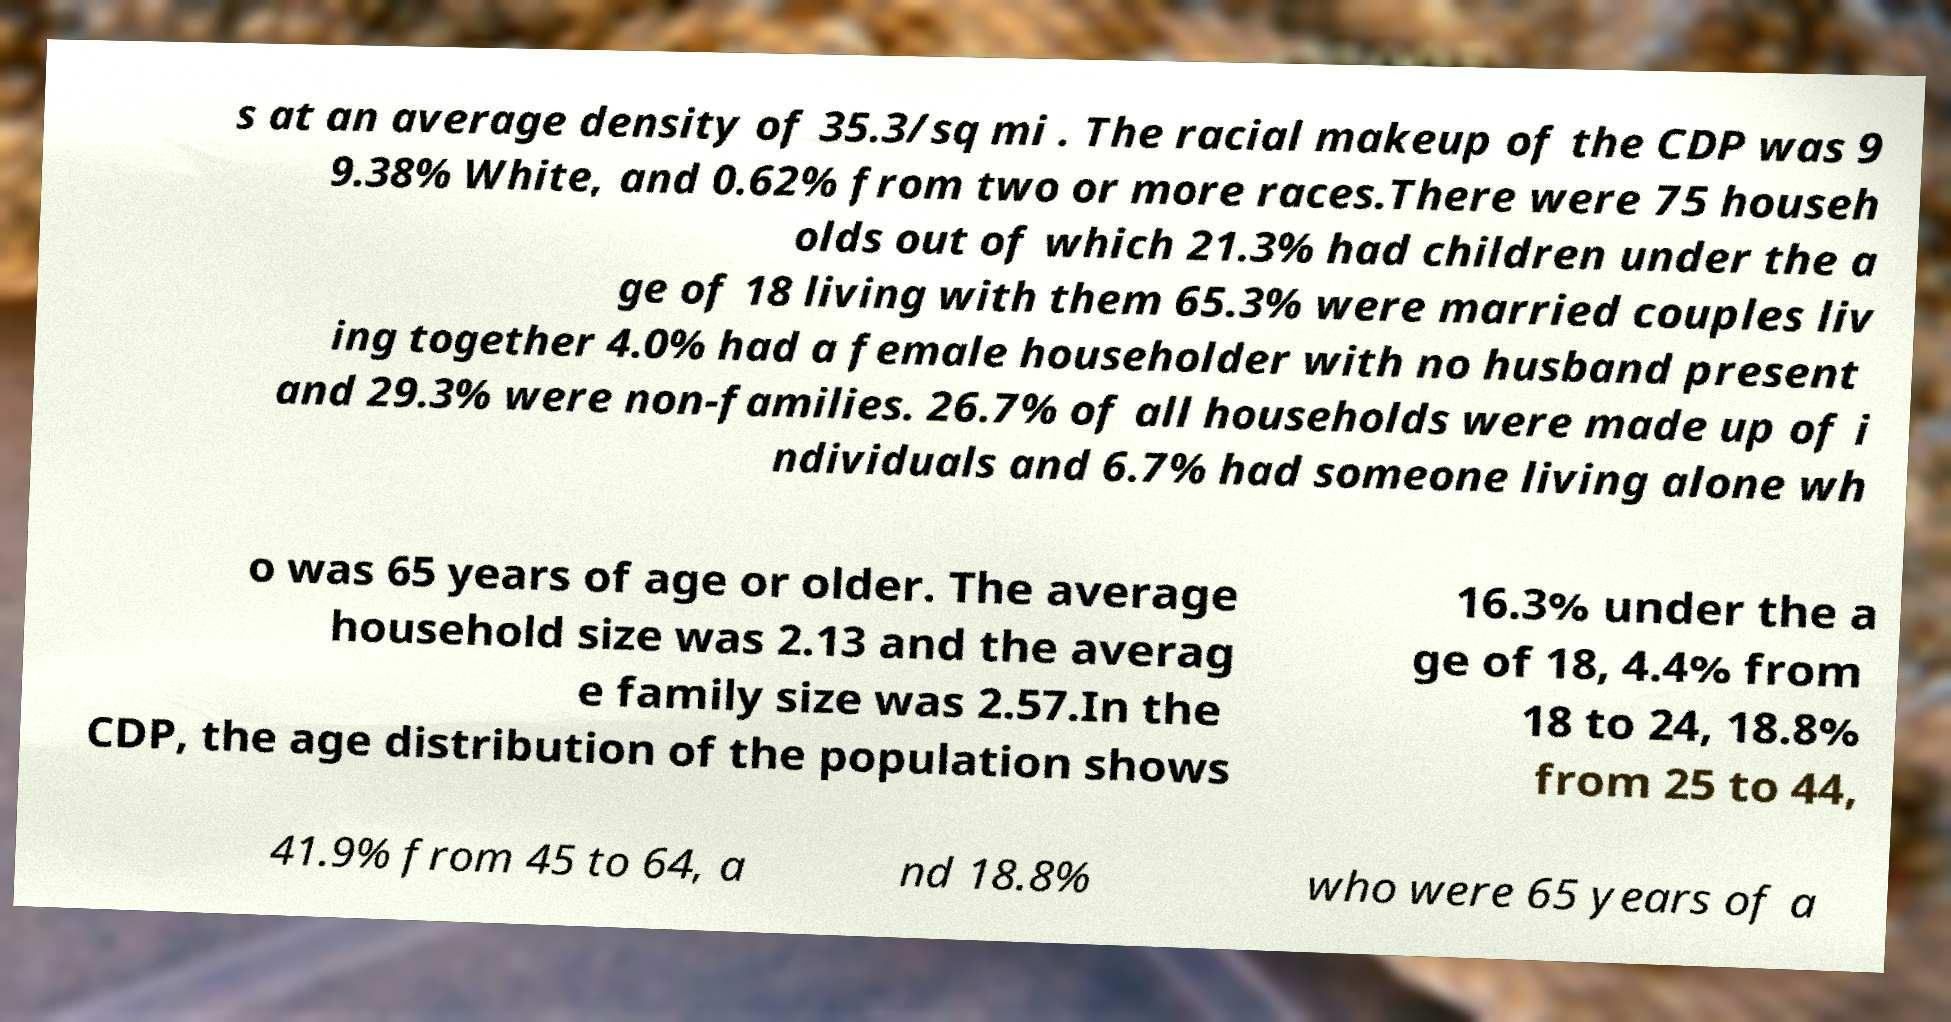Could you extract and type out the text from this image? s at an average density of 35.3/sq mi . The racial makeup of the CDP was 9 9.38% White, and 0.62% from two or more races.There were 75 househ olds out of which 21.3% had children under the a ge of 18 living with them 65.3% were married couples liv ing together 4.0% had a female householder with no husband present and 29.3% were non-families. 26.7% of all households were made up of i ndividuals and 6.7% had someone living alone wh o was 65 years of age or older. The average household size was 2.13 and the averag e family size was 2.57.In the CDP, the age distribution of the population shows 16.3% under the a ge of 18, 4.4% from 18 to 24, 18.8% from 25 to 44, 41.9% from 45 to 64, a nd 18.8% who were 65 years of a 